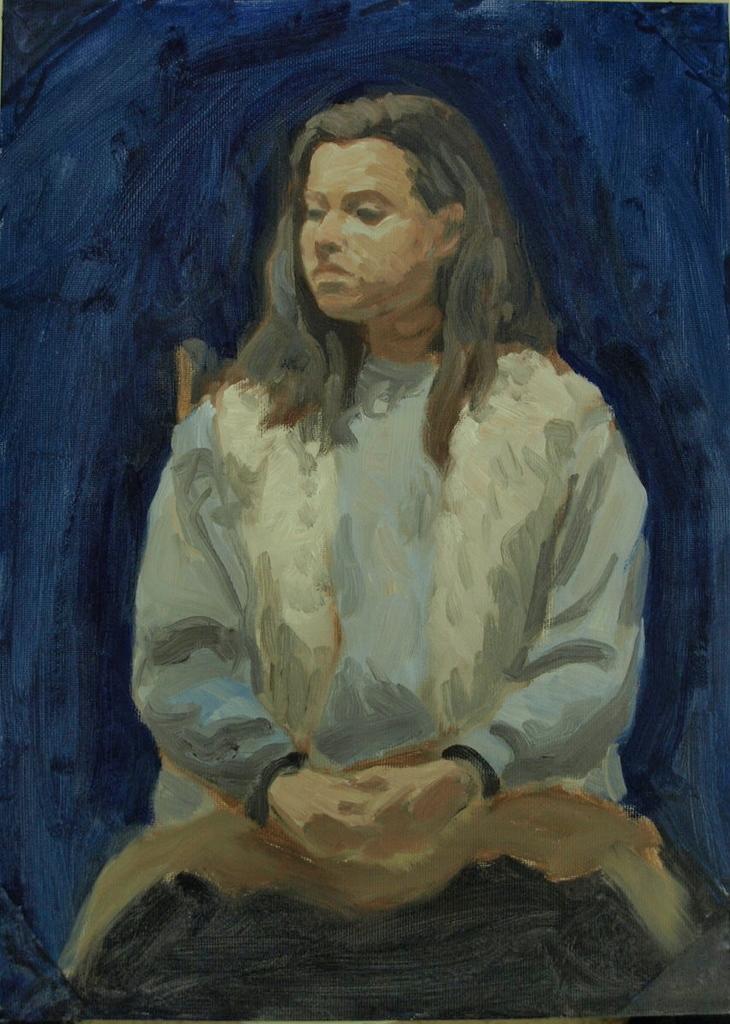How would you summarize this image in a sentence or two? In this image I can see the painting of the person and the person is wearing blue and white color dress and I can see blue color background. 